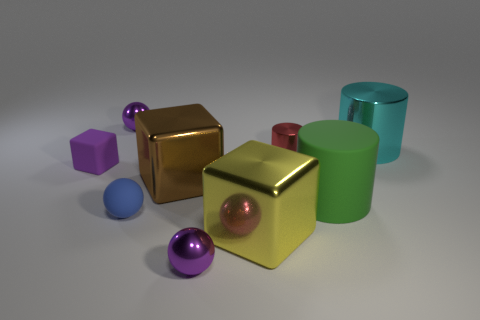Is the number of red objects behind the big cyan shiny cylinder less than the number of tiny purple spheres that are in front of the brown cube?
Ensure brevity in your answer.  Yes. There is a large matte thing that is the same shape as the small red metal object; what is its color?
Offer a very short reply. Green. Does the block that is on the left side of the blue matte ball have the same size as the tiny blue matte object?
Ensure brevity in your answer.  Yes. Is the number of large yellow shiny objects that are on the left side of the tiny blue sphere less than the number of metallic cylinders?
Offer a very short reply. Yes. Is there anything else that is the same size as the purple matte object?
Make the answer very short. Yes. There is a metallic block that is right of the shiny sphere that is in front of the small purple matte object; what size is it?
Your response must be concise. Large. Is there any other thing that has the same shape as the big green matte thing?
Provide a short and direct response. Yes. Is the number of matte blocks less than the number of purple metal spheres?
Your response must be concise. Yes. What material is the cylinder that is left of the big cyan metal thing and behind the purple matte cube?
Ensure brevity in your answer.  Metal. There is a block in front of the green matte cylinder; is there a large thing on the left side of it?
Your answer should be compact. Yes. 